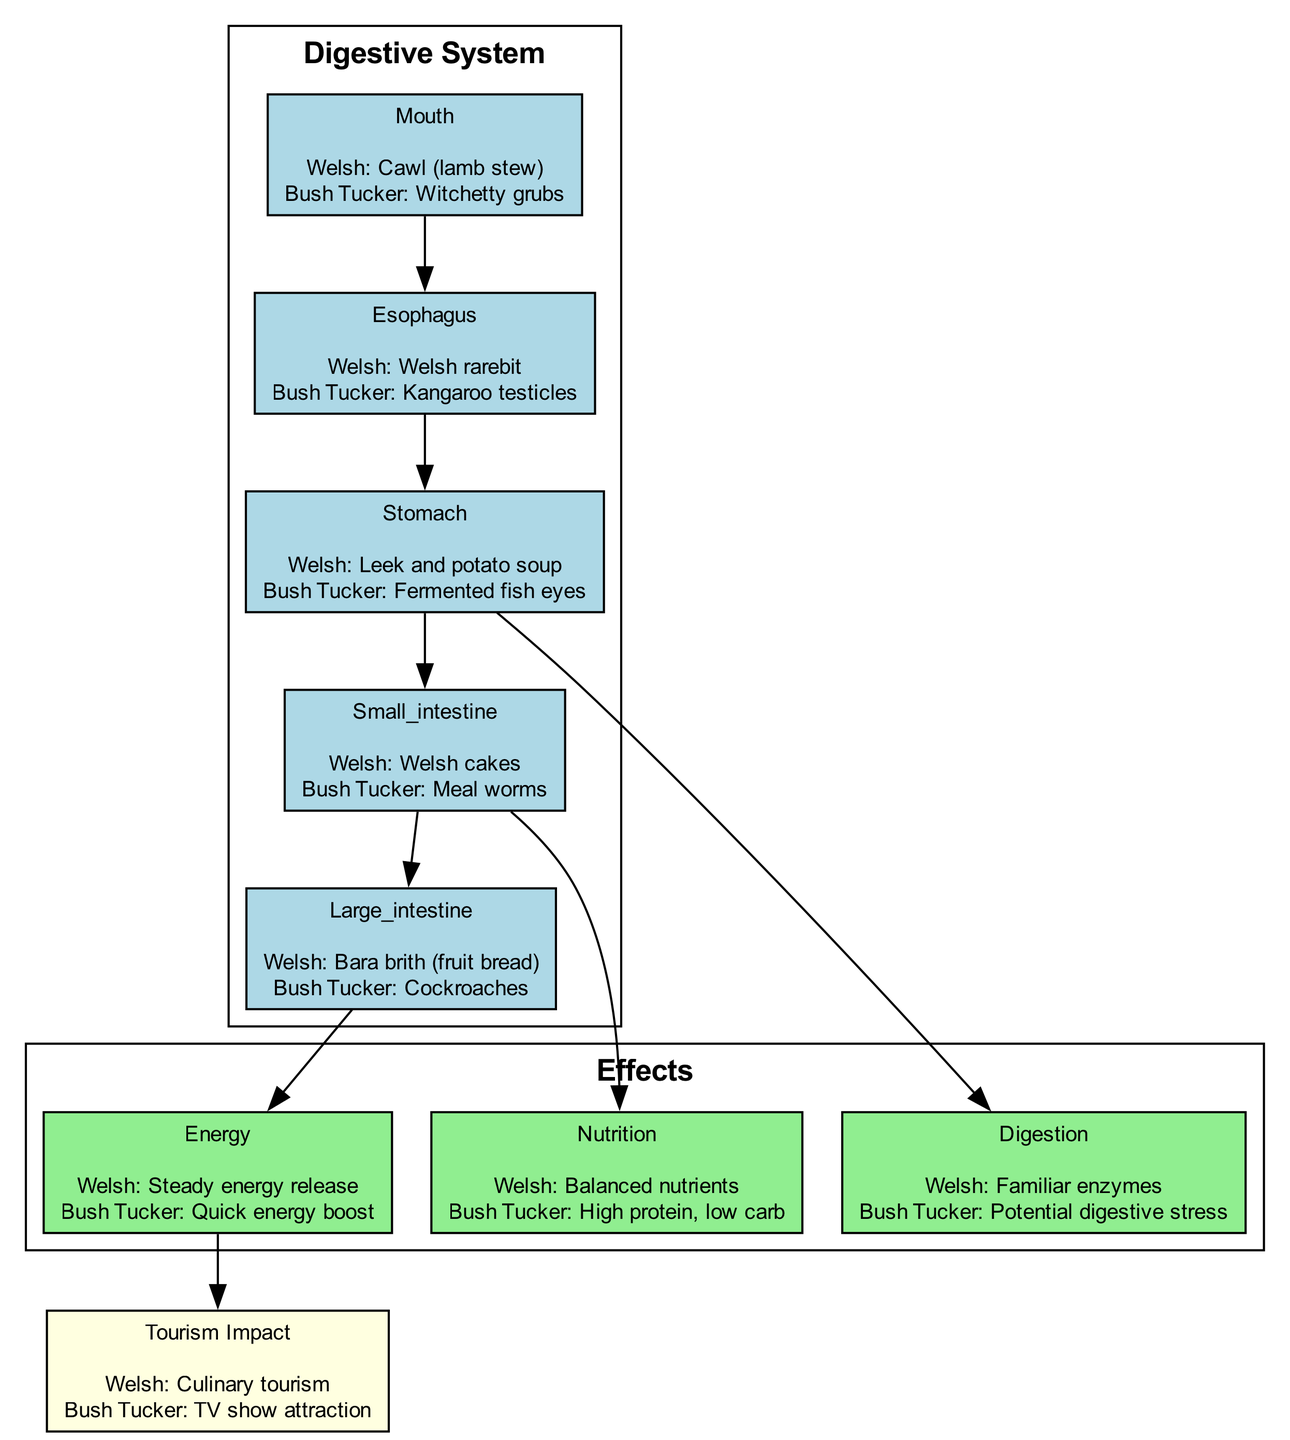What food item is associated with the mouth in traditional Welsh cuisine? The diagram indicates that the food item linked to the mouth in traditional Welsh cuisine is "Cawl (lamb stew)." This information is directly stated in the mouth section of the digestive system.
Answer: Cawl (lamb stew) What food is listed under the esophagus for bush tucker? The bush tucker food item in the esophagus section is "Kangaroo testicles," as shown in the diagram's esophagus node.
Answer: Kangaroo testicles How many organs are depicted in the digestive system section? By counting the nodes in the digestive system section, there are five organs represented: mouth, esophagus, stomach, small intestine, and large intestine.
Answer: 5 What type of energy release is associated with traditional Welsh cuisine? The diagram states that traditional Welsh cuisine is linked to "Steady energy release," located in the energy effects node.
Answer: Steady energy release What is the relationship between the small intestine and nutrition in the effects section? The diagram shows a direct edge indicating that the small intestine is connected to the nutrition effects. This means that foods processed by the small intestine have implications for nutrition.
Answer: Nutrition What is the overall tourism impact associated with traditional Welsh cuisine? The tourism impact node specifies that traditional Welsh cuisine is connected to "Culinary tourism," which is stated directly in that node of the diagram.
Answer: Culinary tourism What are the potential digestive effects of bush tucker foods? The digestive effect node indicates that bush tucker foods may cause "Potential digestive stress," reflecting concerns over digesting these types of foods, as highlighted in the diagram.
Answer: Potential digestive stress How do bush tucker foods compare in terms of nutrition to traditional Welsh cuisine? The nutrition effects node shows that bush tucker foods are categorized as "High protein, low carb," while traditional Welsh cuisine offers "Balanced nutrients," indicating a significant difference in nutritional profiles.
Answer: High protein, low carb What does the arrow from energy effects to tourism impact signify? The diagram illustrates that there is a connection from the energy effects node to the tourism impact node, suggesting that the energy provided by foods may influence the appeal of specific cuisines for tourism, particularly in this context.
Answer: Connection 